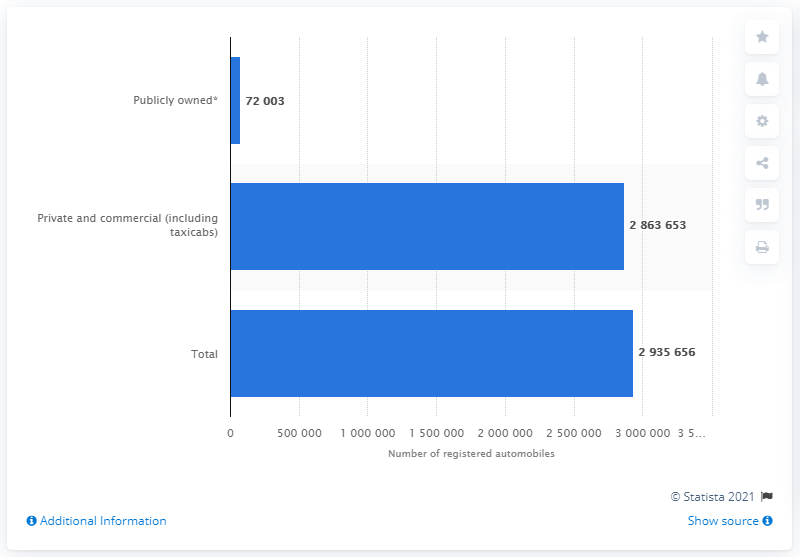Outline some significant characteristics in this image. In 2016, a total of 286,365,378 private and commercial automobiles were registered in the state of Washington. 